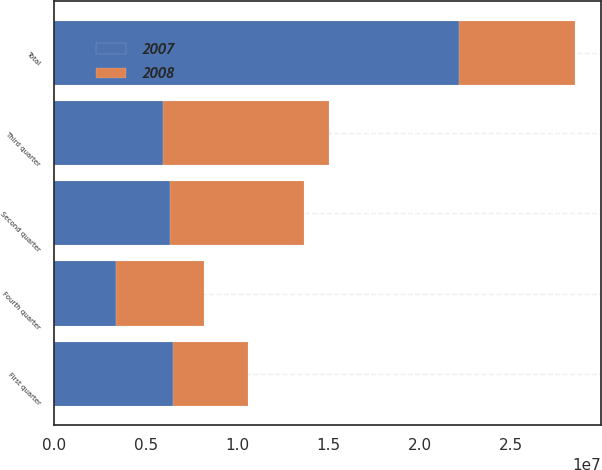Convert chart to OTSL. <chart><loc_0><loc_0><loc_500><loc_500><stacked_bar_chart><ecel><fcel>First quarter<fcel>Second quarter<fcel>Third quarter<fcel>Fourth quarter<fcel>Total<nl><fcel>2007<fcel>6.51228e+06<fcel>6.3372e+06<fcel>5.94311e+06<fcel>3.38328e+06<fcel>2.21759e+07<nl><fcel>2008<fcel>4.088e+06<fcel>7.2994e+06<fcel>9.06404e+06<fcel>4.7956e+06<fcel>6.3372e+06<nl></chart> 